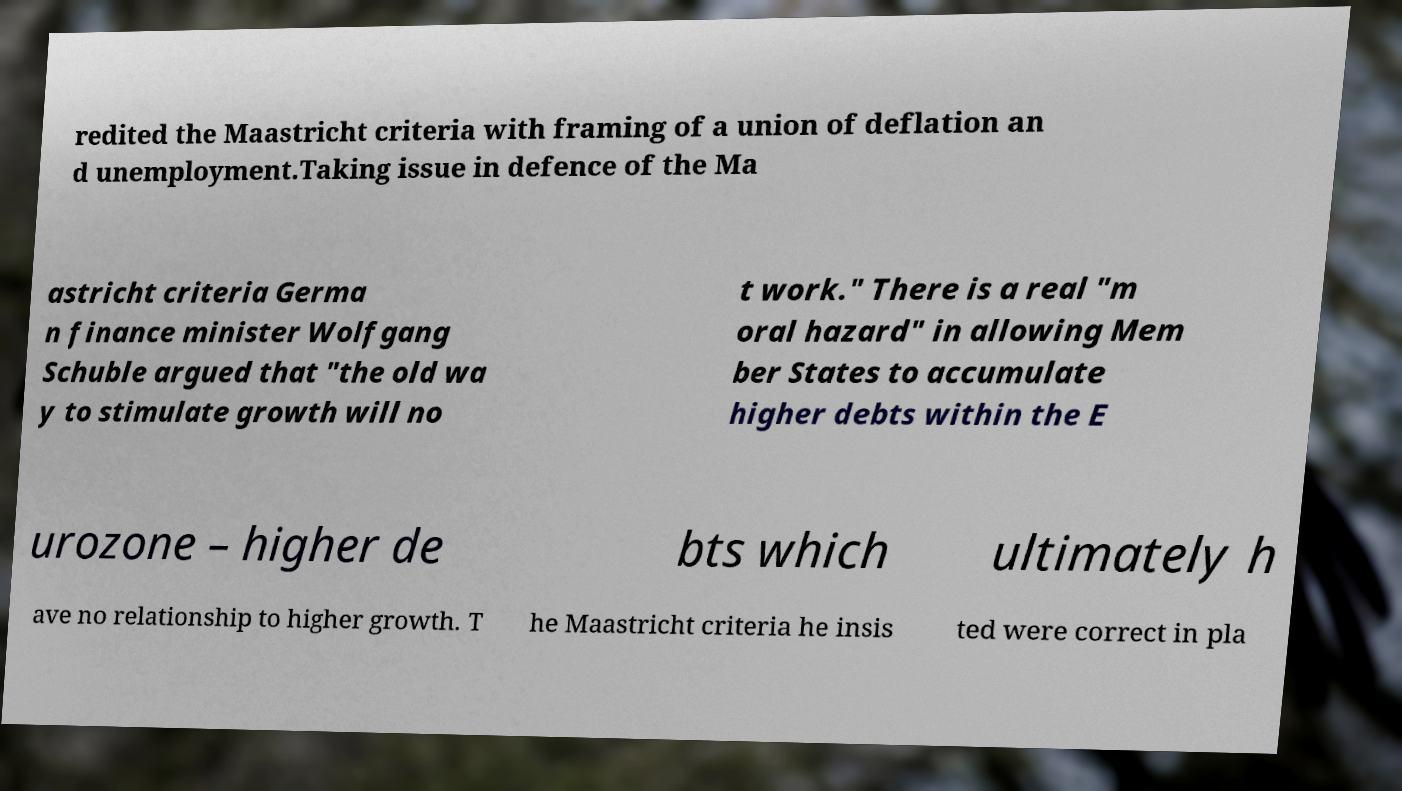For documentation purposes, I need the text within this image transcribed. Could you provide that? redited the Maastricht criteria with framing of a union of deflation an d unemployment.Taking issue in defence of the Ma astricht criteria Germa n finance minister Wolfgang Schuble argued that "the old wa y to stimulate growth will no t work." There is a real "m oral hazard" in allowing Mem ber States to accumulate higher debts within the E urozone – higher de bts which ultimately h ave no relationship to higher growth. T he Maastricht criteria he insis ted were correct in pla 